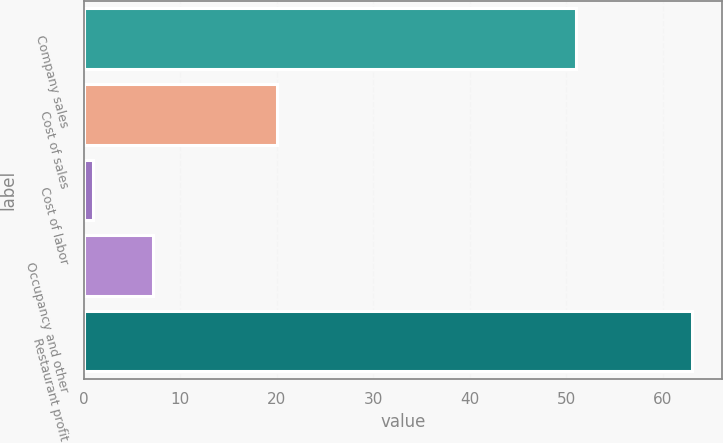<chart> <loc_0><loc_0><loc_500><loc_500><bar_chart><fcel>Company sales<fcel>Cost of sales<fcel>Cost of labor<fcel>Occupancy and other<fcel>Restaurant profit<nl><fcel>51<fcel>20<fcel>1<fcel>7.2<fcel>63<nl></chart> 